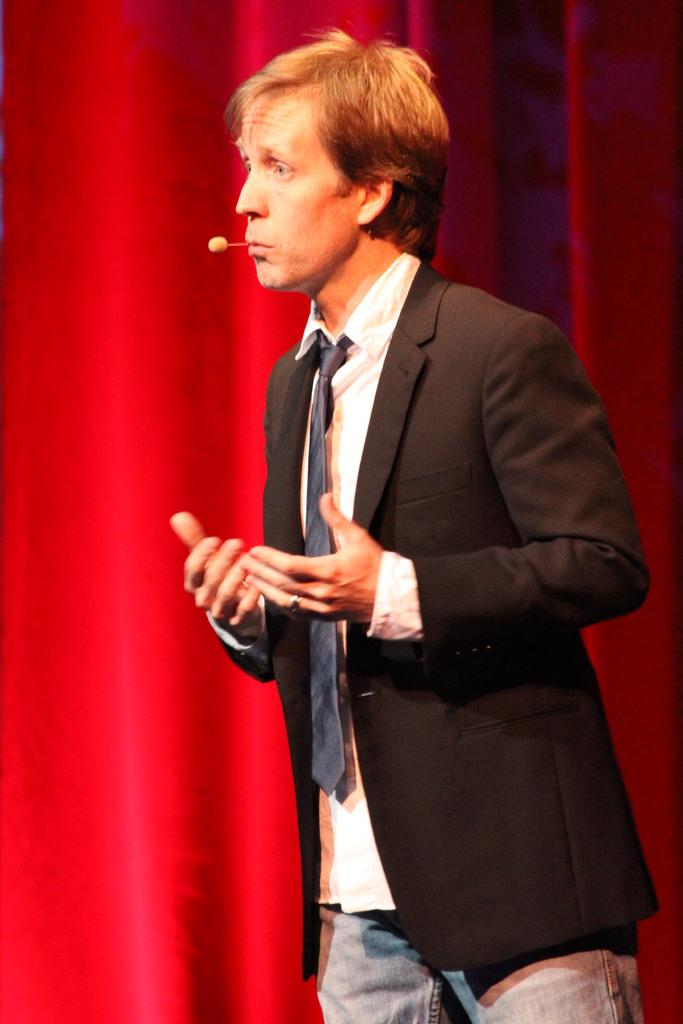What is the main subject of the image? There is a man standing in the image. What is the man doing in the image? The man is talking in the image. What object is present that might be used for amplifying the man's voice? There is a mini microphone in the image. What can be seen in the background of the image? There is a red curtain in the background of the image. How does the man begin his attack in the image? There is no attack depicted in the image; the man is simply talking. What type of sky can be seen in the image? The image does not show the sky; it focuses on the man and the red curtain in the background. 